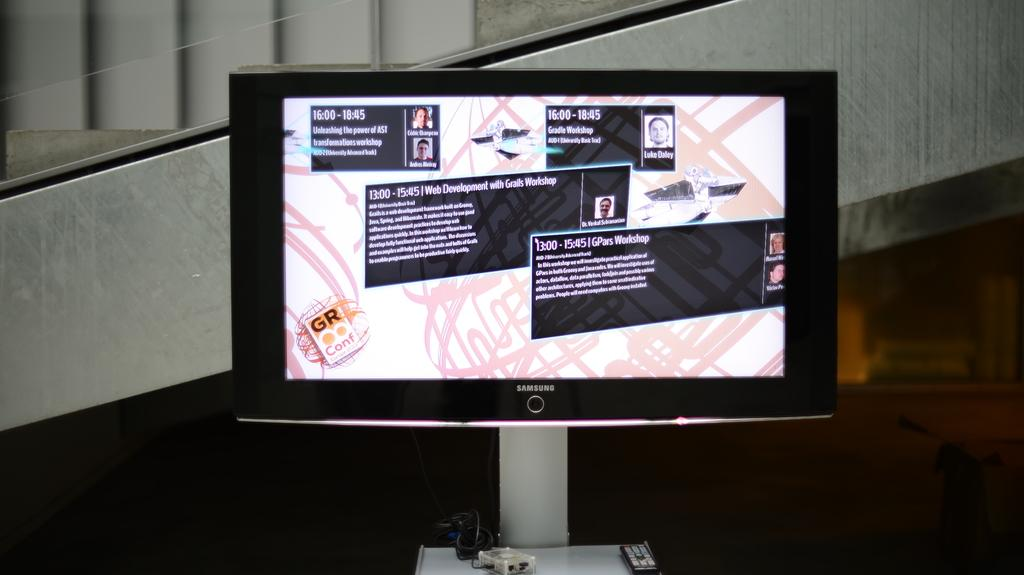<image>
Give a short and clear explanation of the subsequent image. A monitor made by samsung shows some information. 